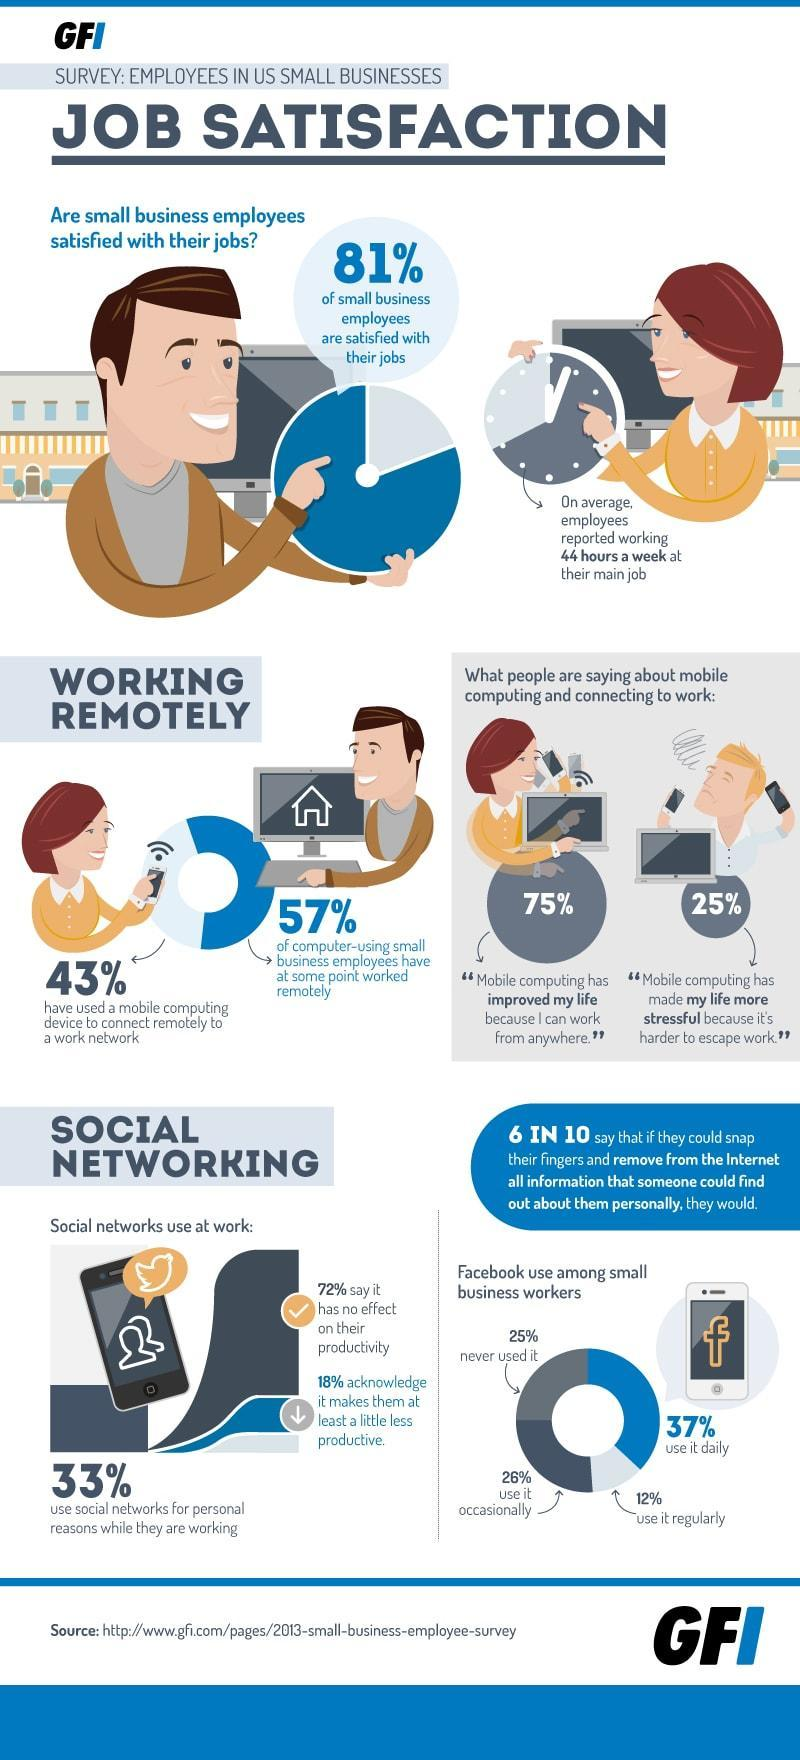Which social media is used daily by 37% of small business workers?
Answer the question with a short phrase. Facebook What percent of people think mobile computing is favourable because they can work from anywhere? 75% What percent of small business employees are not satisfied with their jobs? 19% 